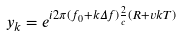Convert formula to latex. <formula><loc_0><loc_0><loc_500><loc_500>y _ { k } = e ^ { i 2 \pi ( f _ { 0 } + k \Delta f ) \frac { 2 } { c } ( R + v k T ) }</formula> 